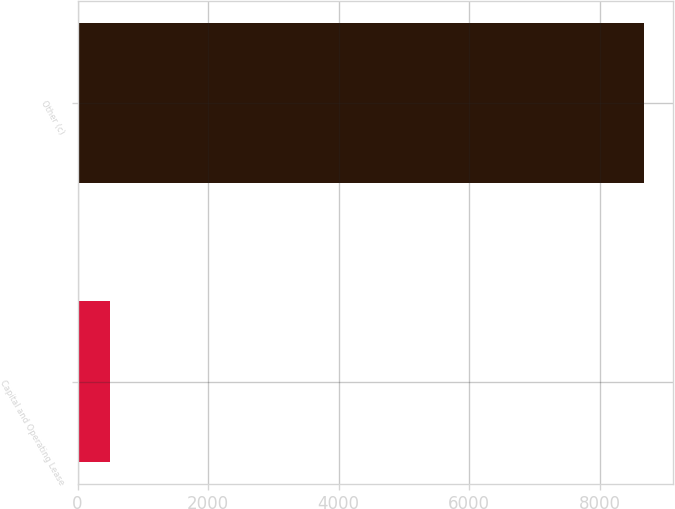<chart> <loc_0><loc_0><loc_500><loc_500><bar_chart><fcel>Capital and Operating Lease<fcel>Other (c)<nl><fcel>495<fcel>8687<nl></chart> 